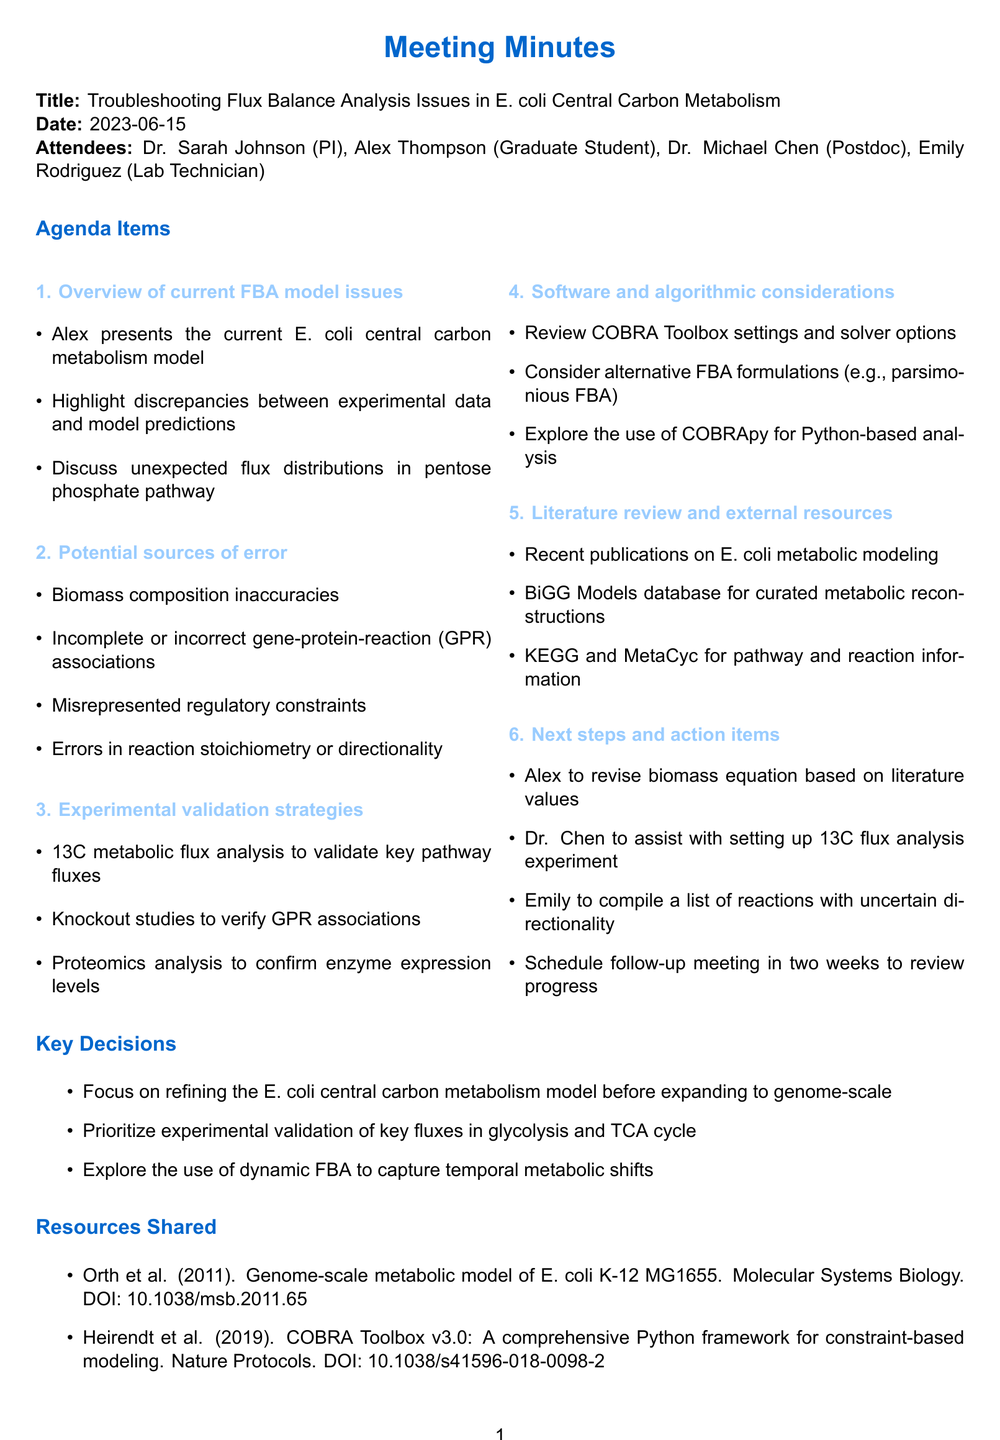What was the meeting date? The meeting date is explicitly stated in the document for reference.
Answer: 2023-06-15 Who is the principal investigator (PI) mentioned in the minutes? The PI is mentioned among the attendees, indicating their role in the meeting.
Answer: Dr. Sarah Johnson What is the main focus of this meeting? The title of the meeting summarizes the main discussion points related to flux balance analysis.
Answer: Troubleshooting Flux Balance Analysis Issues in E. coli Central Carbon Metabolism What are the key experimental validation strategies discussed? The document provides specific strategies in the section dedicated to experimental validation.
Answer: 13C metabolic flux analysis to validate key pathway fluxes Which software was suggested for analysis? The meeting minutes mention specific software solutions relevant to the analysis being discussed.
Answer: COBRApy What is the duration until the follow-up meeting? The follow-up meeting is set in the context of the next steps and timelines discussed.
Answer: Two weeks What is one identified source of error in the FBA model? Several sources of error are listed, and one can be selected as representative from the document.
Answer: Biomass composition inaccuracies What were the key decisions made during the meeting? The decisions are summarized clearly in a specific section of the minutes.
Answer: Focus on refining the E. coli central carbon metabolism model before expanding to genome-scale 